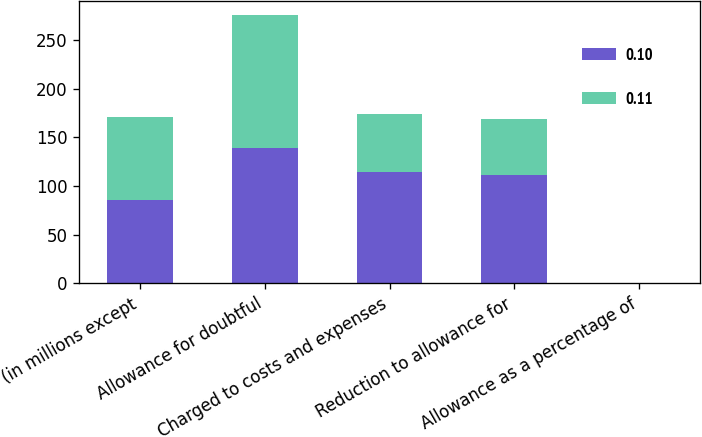Convert chart to OTSL. <chart><loc_0><loc_0><loc_500><loc_500><stacked_bar_chart><ecel><fcel>(in millions except<fcel>Allowance for doubtful<fcel>Charged to costs and expenses<fcel>Reduction to allowance for<fcel>Allowance as a percentage of<nl><fcel>0.1<fcel>85.5<fcel>139<fcel>114<fcel>111<fcel>0.1<nl><fcel>0.11<fcel>85.5<fcel>137<fcel>60<fcel>58<fcel>0.11<nl></chart> 